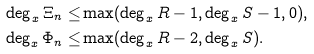Convert formula to latex. <formula><loc_0><loc_0><loc_500><loc_500>\deg _ { x } \Xi _ { n } \leq & \max ( \deg _ { x } R - 1 , \deg _ { x } S - 1 , 0 ) , \\ \deg _ { x } \Phi _ { n } \leq & \max ( \deg _ { x } R - 2 , \deg _ { x } S ) .</formula> 